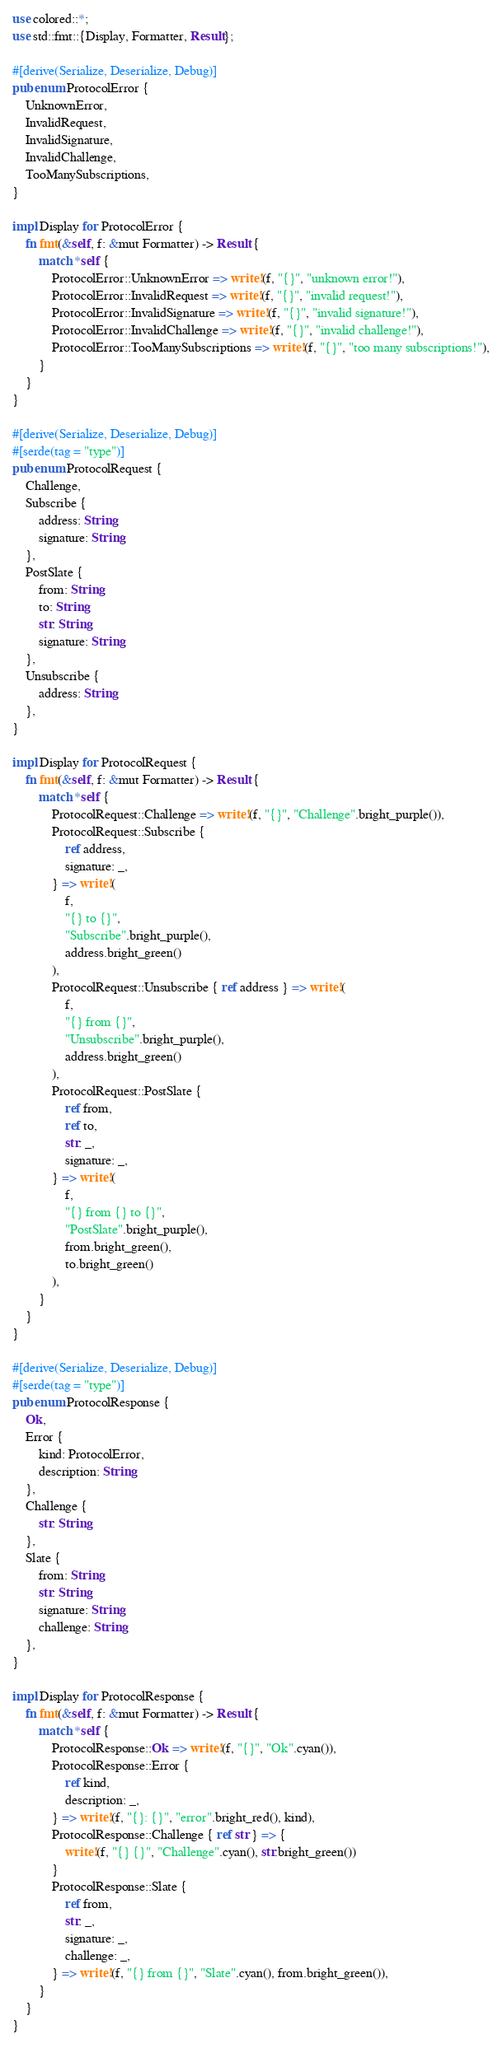<code> <loc_0><loc_0><loc_500><loc_500><_Rust_>use colored::*;
use std::fmt::{Display, Formatter, Result};

#[derive(Serialize, Deserialize, Debug)]
pub enum ProtocolError {
	UnknownError,
	InvalidRequest,
	InvalidSignature,
	InvalidChallenge,
	TooManySubscriptions,
}

impl Display for ProtocolError {
	fn fmt(&self, f: &mut Formatter) -> Result {
		match *self {
			ProtocolError::UnknownError => write!(f, "{}", "unknown error!"),
			ProtocolError::InvalidRequest => write!(f, "{}", "invalid request!"),
			ProtocolError::InvalidSignature => write!(f, "{}", "invalid signature!"),
			ProtocolError::InvalidChallenge => write!(f, "{}", "invalid challenge!"),
			ProtocolError::TooManySubscriptions => write!(f, "{}", "too many subscriptions!"),
		}
	}
}

#[derive(Serialize, Deserialize, Debug)]
#[serde(tag = "type")]
pub enum ProtocolRequest {
	Challenge,
	Subscribe {
		address: String,
		signature: String,
	},
	PostSlate {
		from: String,
		to: String,
		str: String,
		signature: String,
	},
	Unsubscribe {
		address: String,
	},
}

impl Display for ProtocolRequest {
	fn fmt(&self, f: &mut Formatter) -> Result {
		match *self {
			ProtocolRequest::Challenge => write!(f, "{}", "Challenge".bright_purple()),
			ProtocolRequest::Subscribe {
				ref address,
				signature: _,
			} => write!(
				f,
				"{} to {}",
				"Subscribe".bright_purple(),
				address.bright_green()
			),
			ProtocolRequest::Unsubscribe { ref address } => write!(
				f,
				"{} from {}",
				"Unsubscribe".bright_purple(),
				address.bright_green()
			),
			ProtocolRequest::PostSlate {
				ref from,
				ref to,
				str: _,
				signature: _,
			} => write!(
				f,
				"{} from {} to {}",
				"PostSlate".bright_purple(),
				from.bright_green(),
				to.bright_green()
			),
		}
	}
}

#[derive(Serialize, Deserialize, Debug)]
#[serde(tag = "type")]
pub enum ProtocolResponse {
	Ok,
	Error {
		kind: ProtocolError,
		description: String,
	},
	Challenge {
		str: String,
	},
	Slate {
		from: String,
		str: String,
		signature: String,
		challenge: String,
	},
}

impl Display for ProtocolResponse {
	fn fmt(&self, f: &mut Formatter) -> Result {
		match *self {
			ProtocolResponse::Ok => write!(f, "{}", "Ok".cyan()),
			ProtocolResponse::Error {
				ref kind,
				description: _,
			} => write!(f, "{}: {}", "error".bright_red(), kind),
			ProtocolResponse::Challenge { ref str } => {
				write!(f, "{} {}", "Challenge".cyan(), str.bright_green())
			}
			ProtocolResponse::Slate {
				ref from,
				str: _,
				signature: _,
				challenge: _,
			} => write!(f, "{} from {}", "Slate".cyan(), from.bright_green()),
		}
	}
}
</code> 